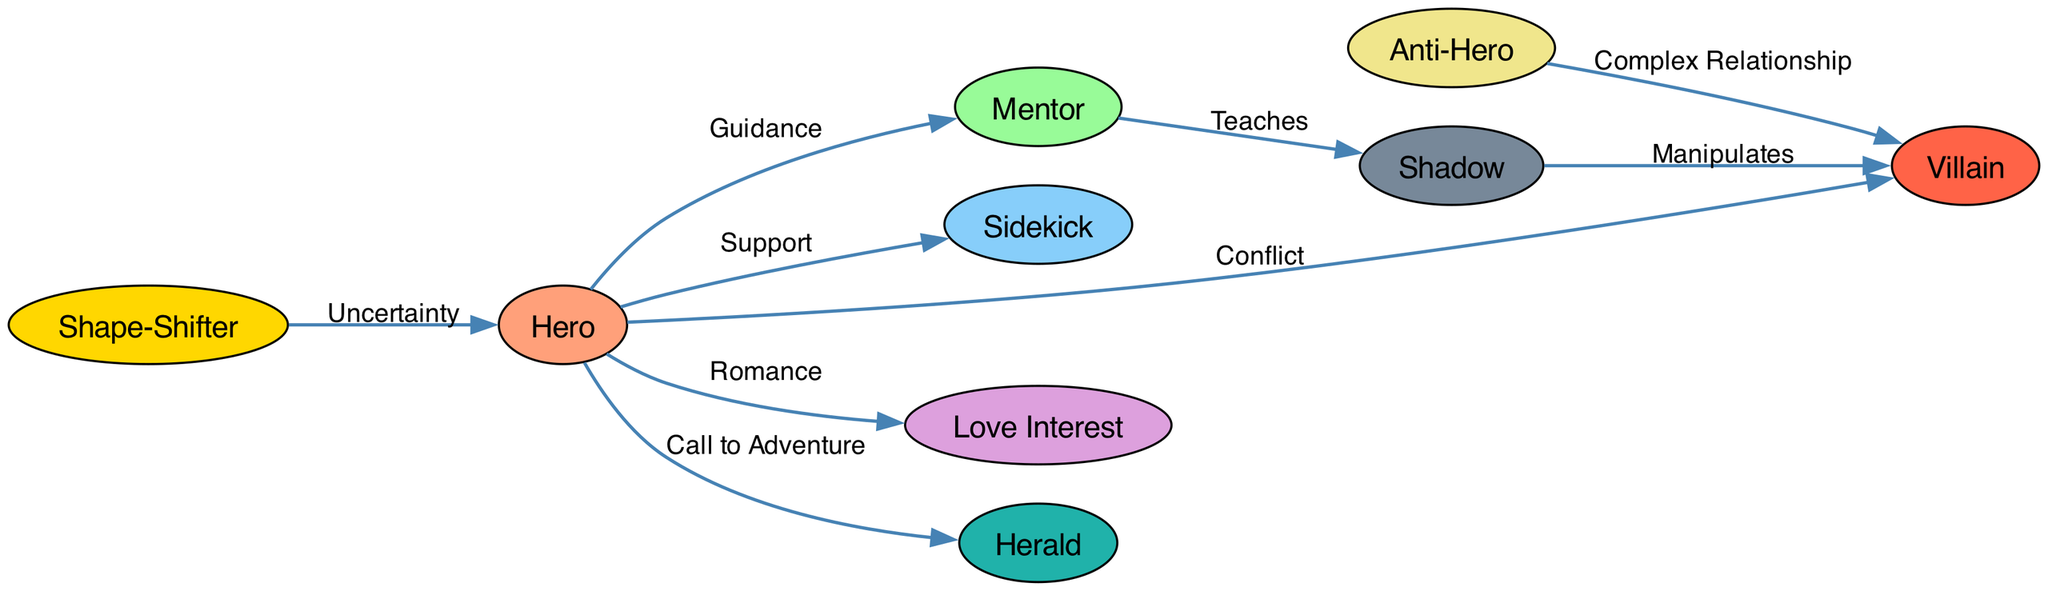What are the main character archetypes represented in the diagram? The diagram includes nine character archetypes: Hero, Mentor, Sidekick, Villain, Love Interest, Anti-Hero, Herald, Shape-Shifter, and Shadow. These nodes are explicitly listed in the diagram itself.
Answer: Hero, Mentor, Sidekick, Villain, Love Interest, Anti-Hero, Herald, Shape-Shifter, Shadow How many edges are present in the diagram? By counting the connections (edges) in the diagram, there are a total of eight edges linking the various character archetypes.
Answer: 8 What relationship connects the Hero and Mentor archetypes? The diagram shows a directed edge from Hero to Mentor labeled as "Guidance," indicating the specific relationship between these two archetypes.
Answer: Guidance Which archetype has a direct relationship with both Villain and Anti-Hero? The Anti-Hero is connected to the Villain through a "Complex Relationship" edge, indicating it interacts with the Villain while also being its own archetype in the diagram.
Answer: Anti-Hero What role does the Herald play in relation to the Hero? The edge labeled "Call to Adventure" connects the Hero to the Herald, indicating that the Herald serves the role of prompting or sparking the Hero's journey in the narrative.
Answer: Call to Adventure Which archetype is shown to teach the Shadow? The Mentor is connected to the Shadow with an edge labeled "Teaches," indicating that the Mentor has a role in instructing or imparting knowledge to the Shadow archetype.
Answer: Mentor What kind of relationship exists between the Shadow and the Villain archetypes? There is a connection from Shadow to Villain labeled "Manipulates," indicating that the Shadow archetype has an influence or manipulation role concerning the Villain in the narrative.
Answer: Manipulates Which archetype introduces uncertainty in relation to the Hero? The Shape-Shifter has a directed edge labeled "Uncertainty" pointing to the Hero, indicating that it introduces an element of unpredictability or ambiguity in the Hero's journey.
Answer: Shape-Shifter How many character archetypes act as a source of conflict for the Hero? The diagram shows that there are three archetypes that create a source of conflict for the Hero: the Villain, Shadow (through manipulation), and the Anti-Hero (having a complex relationship) which implies conflicts or challenges in the Hero's path.
Answer: 3 